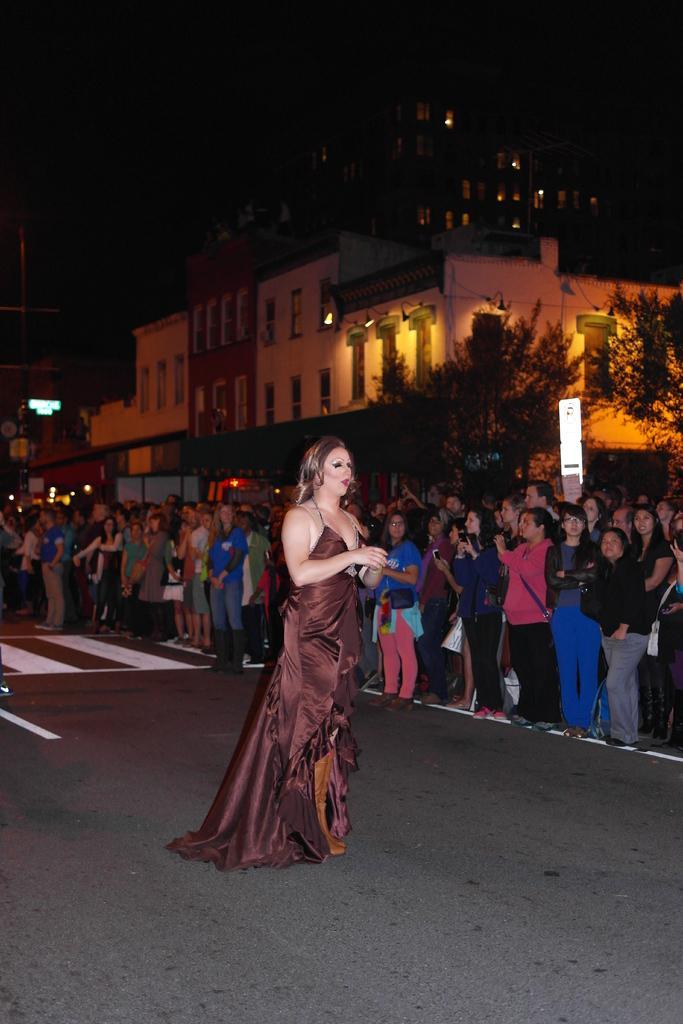How would you summarize this image in a sentence or two? In the image in the center, we can see one woman standing on the road. In the background, we can see buildings, windows, trees, banners, the lights and group of people are standing. 